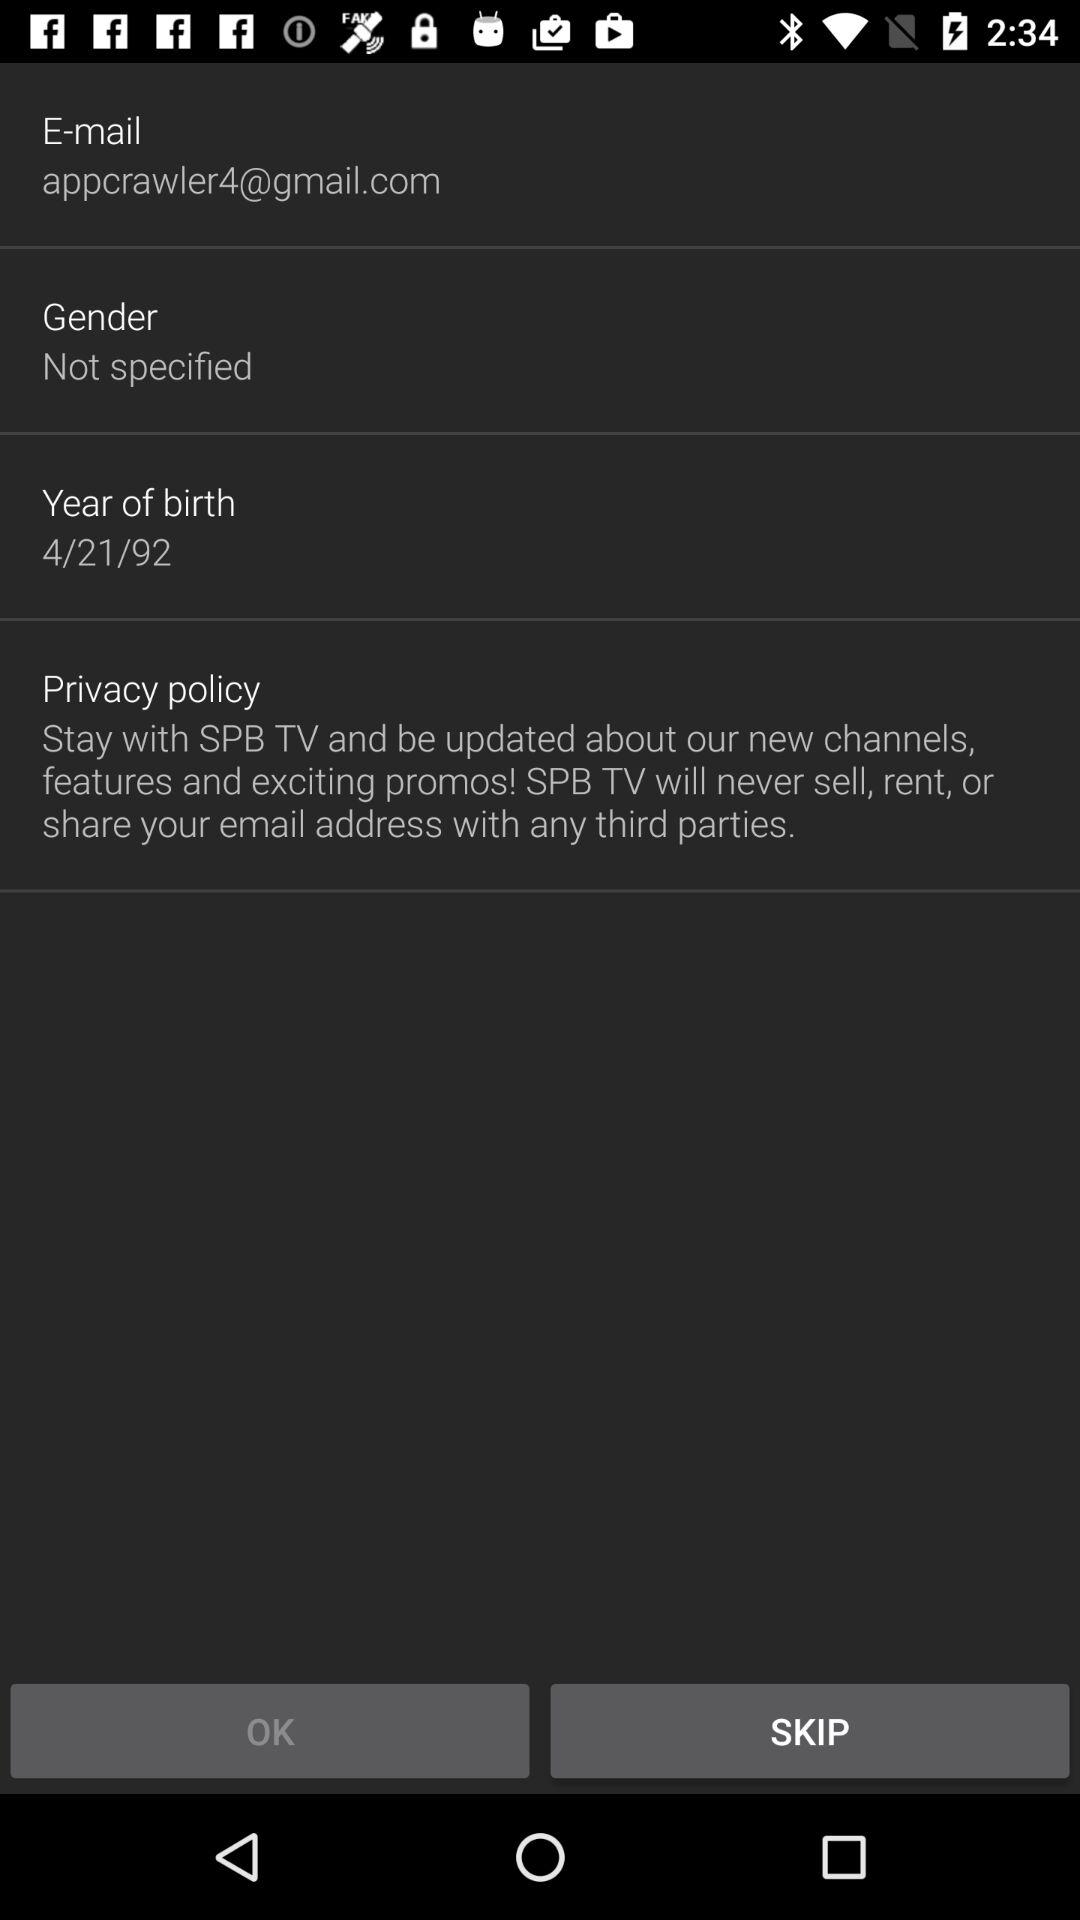What is the date of birth? The date of birth is April 21, 1992. 